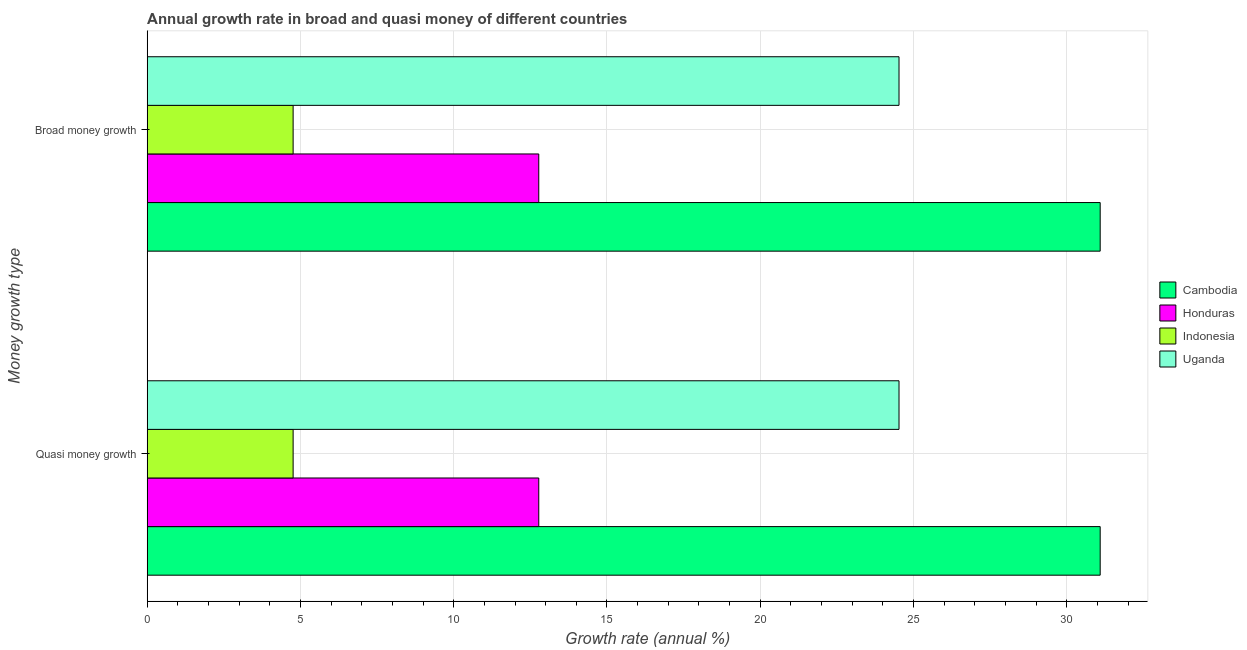Are the number of bars per tick equal to the number of legend labels?
Your response must be concise. Yes. How many bars are there on the 2nd tick from the bottom?
Make the answer very short. 4. What is the label of the 1st group of bars from the top?
Keep it short and to the point. Broad money growth. What is the annual growth rate in broad money in Honduras?
Offer a very short reply. 12.77. Across all countries, what is the maximum annual growth rate in broad money?
Provide a short and direct response. 31.09. Across all countries, what is the minimum annual growth rate in broad money?
Ensure brevity in your answer.  4.76. In which country was the annual growth rate in quasi money maximum?
Your answer should be very brief. Cambodia. What is the total annual growth rate in broad money in the graph?
Your response must be concise. 73.15. What is the difference between the annual growth rate in broad money in Indonesia and that in Uganda?
Your answer should be compact. -19.77. What is the difference between the annual growth rate in quasi money in Cambodia and the annual growth rate in broad money in Uganda?
Provide a succinct answer. 6.56. What is the average annual growth rate in broad money per country?
Ensure brevity in your answer.  18.29. In how many countries, is the annual growth rate in broad money greater than 10 %?
Your response must be concise. 3. What is the ratio of the annual growth rate in quasi money in Honduras to that in Cambodia?
Your answer should be very brief. 0.41. What does the 4th bar from the top in Broad money growth represents?
Your response must be concise. Cambodia. Are all the bars in the graph horizontal?
Offer a terse response. Yes. How many countries are there in the graph?
Provide a short and direct response. 4. Are the values on the major ticks of X-axis written in scientific E-notation?
Your answer should be very brief. No. Does the graph contain any zero values?
Your answer should be compact. No. Does the graph contain grids?
Your answer should be very brief. Yes. Where does the legend appear in the graph?
Your answer should be compact. Center right. How are the legend labels stacked?
Your answer should be compact. Vertical. What is the title of the graph?
Provide a succinct answer. Annual growth rate in broad and quasi money of different countries. What is the label or title of the X-axis?
Ensure brevity in your answer.  Growth rate (annual %). What is the label or title of the Y-axis?
Provide a short and direct response. Money growth type. What is the Growth rate (annual %) in Cambodia in Quasi money growth?
Provide a succinct answer. 31.09. What is the Growth rate (annual %) in Honduras in Quasi money growth?
Offer a very short reply. 12.77. What is the Growth rate (annual %) of Indonesia in Quasi money growth?
Give a very brief answer. 4.76. What is the Growth rate (annual %) of Uganda in Quasi money growth?
Offer a terse response. 24.53. What is the Growth rate (annual %) of Cambodia in Broad money growth?
Ensure brevity in your answer.  31.09. What is the Growth rate (annual %) in Honduras in Broad money growth?
Give a very brief answer. 12.77. What is the Growth rate (annual %) in Indonesia in Broad money growth?
Provide a succinct answer. 4.76. What is the Growth rate (annual %) of Uganda in Broad money growth?
Give a very brief answer. 24.53. Across all Money growth type, what is the maximum Growth rate (annual %) in Cambodia?
Offer a very short reply. 31.09. Across all Money growth type, what is the maximum Growth rate (annual %) in Honduras?
Your response must be concise. 12.77. Across all Money growth type, what is the maximum Growth rate (annual %) in Indonesia?
Keep it short and to the point. 4.76. Across all Money growth type, what is the maximum Growth rate (annual %) in Uganda?
Give a very brief answer. 24.53. Across all Money growth type, what is the minimum Growth rate (annual %) in Cambodia?
Give a very brief answer. 31.09. Across all Money growth type, what is the minimum Growth rate (annual %) in Honduras?
Offer a very short reply. 12.77. Across all Money growth type, what is the minimum Growth rate (annual %) of Indonesia?
Provide a short and direct response. 4.76. Across all Money growth type, what is the minimum Growth rate (annual %) in Uganda?
Provide a short and direct response. 24.53. What is the total Growth rate (annual %) of Cambodia in the graph?
Ensure brevity in your answer.  62.18. What is the total Growth rate (annual %) in Honduras in the graph?
Offer a very short reply. 25.55. What is the total Growth rate (annual %) in Indonesia in the graph?
Ensure brevity in your answer.  9.52. What is the total Growth rate (annual %) in Uganda in the graph?
Keep it short and to the point. 49.05. What is the difference between the Growth rate (annual %) of Honduras in Quasi money growth and that in Broad money growth?
Your answer should be compact. 0. What is the difference between the Growth rate (annual %) in Indonesia in Quasi money growth and that in Broad money growth?
Provide a succinct answer. 0. What is the difference between the Growth rate (annual %) of Cambodia in Quasi money growth and the Growth rate (annual %) of Honduras in Broad money growth?
Your answer should be compact. 18.32. What is the difference between the Growth rate (annual %) of Cambodia in Quasi money growth and the Growth rate (annual %) of Indonesia in Broad money growth?
Offer a very short reply. 26.33. What is the difference between the Growth rate (annual %) in Cambodia in Quasi money growth and the Growth rate (annual %) in Uganda in Broad money growth?
Your answer should be compact. 6.56. What is the difference between the Growth rate (annual %) in Honduras in Quasi money growth and the Growth rate (annual %) in Indonesia in Broad money growth?
Offer a terse response. 8.01. What is the difference between the Growth rate (annual %) in Honduras in Quasi money growth and the Growth rate (annual %) in Uganda in Broad money growth?
Offer a terse response. -11.75. What is the difference between the Growth rate (annual %) of Indonesia in Quasi money growth and the Growth rate (annual %) of Uganda in Broad money growth?
Your answer should be compact. -19.77. What is the average Growth rate (annual %) of Cambodia per Money growth type?
Make the answer very short. 31.09. What is the average Growth rate (annual %) in Honduras per Money growth type?
Provide a short and direct response. 12.77. What is the average Growth rate (annual %) of Indonesia per Money growth type?
Your response must be concise. 4.76. What is the average Growth rate (annual %) of Uganda per Money growth type?
Offer a terse response. 24.53. What is the difference between the Growth rate (annual %) of Cambodia and Growth rate (annual %) of Honduras in Quasi money growth?
Provide a short and direct response. 18.32. What is the difference between the Growth rate (annual %) in Cambodia and Growth rate (annual %) in Indonesia in Quasi money growth?
Give a very brief answer. 26.33. What is the difference between the Growth rate (annual %) in Cambodia and Growth rate (annual %) in Uganda in Quasi money growth?
Your answer should be very brief. 6.56. What is the difference between the Growth rate (annual %) in Honduras and Growth rate (annual %) in Indonesia in Quasi money growth?
Provide a succinct answer. 8.01. What is the difference between the Growth rate (annual %) in Honduras and Growth rate (annual %) in Uganda in Quasi money growth?
Provide a succinct answer. -11.75. What is the difference between the Growth rate (annual %) in Indonesia and Growth rate (annual %) in Uganda in Quasi money growth?
Give a very brief answer. -19.77. What is the difference between the Growth rate (annual %) of Cambodia and Growth rate (annual %) of Honduras in Broad money growth?
Ensure brevity in your answer.  18.32. What is the difference between the Growth rate (annual %) in Cambodia and Growth rate (annual %) in Indonesia in Broad money growth?
Your answer should be very brief. 26.33. What is the difference between the Growth rate (annual %) of Cambodia and Growth rate (annual %) of Uganda in Broad money growth?
Offer a very short reply. 6.56. What is the difference between the Growth rate (annual %) in Honduras and Growth rate (annual %) in Indonesia in Broad money growth?
Give a very brief answer. 8.01. What is the difference between the Growth rate (annual %) in Honduras and Growth rate (annual %) in Uganda in Broad money growth?
Give a very brief answer. -11.75. What is the difference between the Growth rate (annual %) in Indonesia and Growth rate (annual %) in Uganda in Broad money growth?
Your response must be concise. -19.77. What is the ratio of the Growth rate (annual %) in Indonesia in Quasi money growth to that in Broad money growth?
Provide a short and direct response. 1. What is the difference between the highest and the second highest Growth rate (annual %) of Cambodia?
Keep it short and to the point. 0. What is the difference between the highest and the second highest Growth rate (annual %) in Honduras?
Give a very brief answer. 0. What is the difference between the highest and the lowest Growth rate (annual %) in Cambodia?
Offer a very short reply. 0. What is the difference between the highest and the lowest Growth rate (annual %) in Honduras?
Make the answer very short. 0. What is the difference between the highest and the lowest Growth rate (annual %) in Uganda?
Your answer should be compact. 0. 